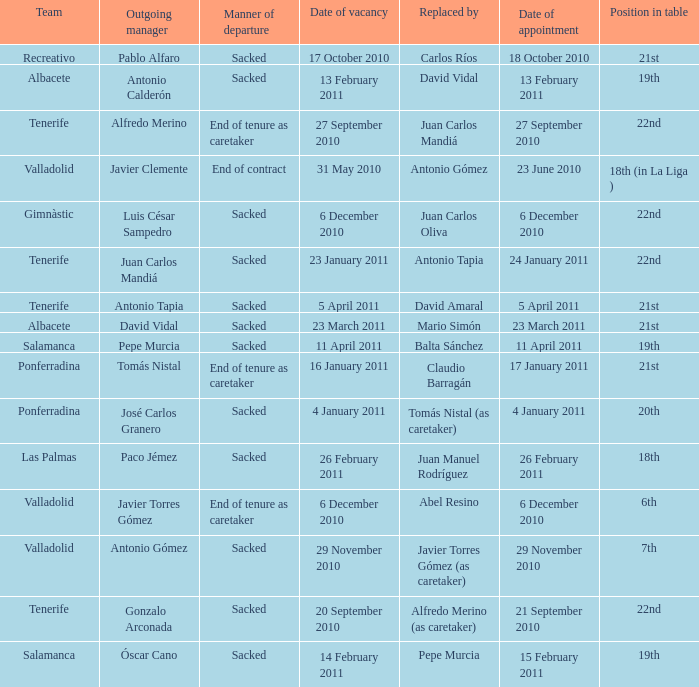What was the manner of departure for the appointment date of 21 september 2010 Sacked. 